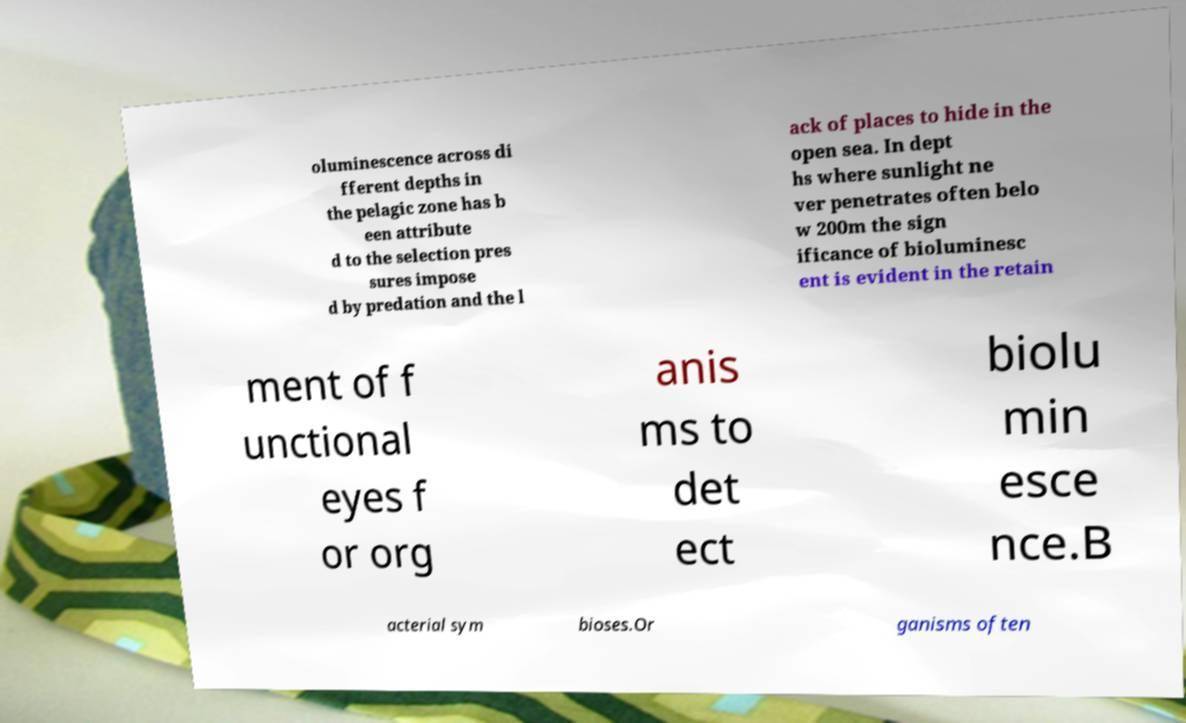Please identify and transcribe the text found in this image. oluminescence across di fferent depths in the pelagic zone has b een attribute d to the selection pres sures impose d by predation and the l ack of places to hide in the open sea. In dept hs where sunlight ne ver penetrates often belo w 200m the sign ificance of bioluminesc ent is evident in the retain ment of f unctional eyes f or org anis ms to det ect biolu min esce nce.B acterial sym bioses.Or ganisms often 